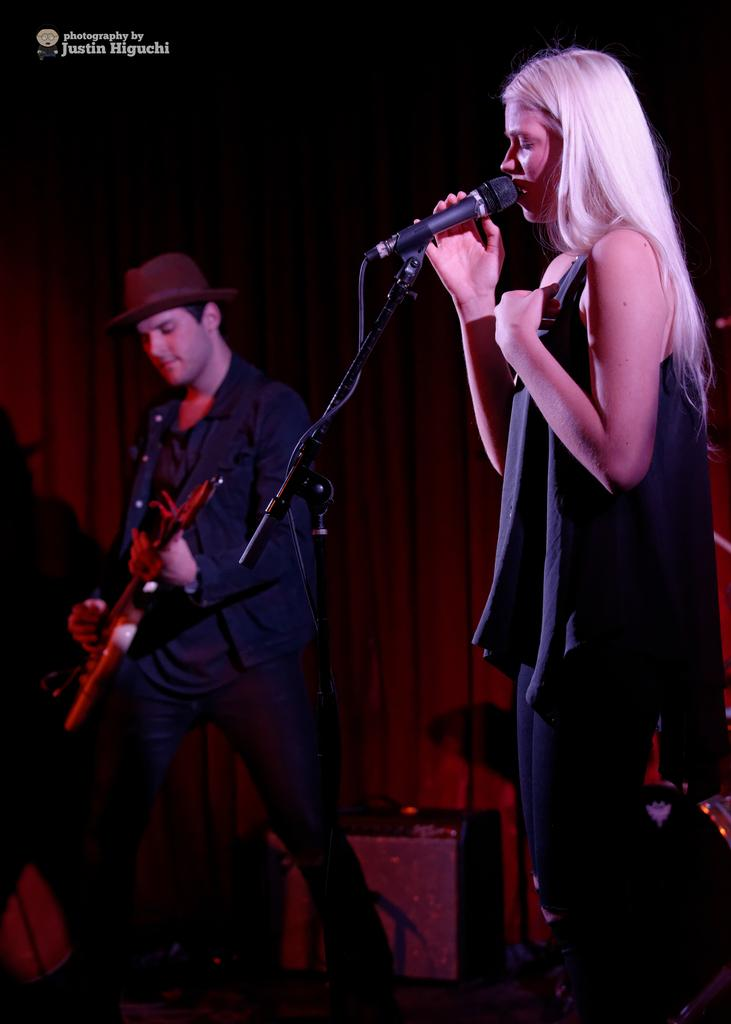What are the two people in the image doing? The man is holding a guitar, and the woman is holding a microphone. Can you describe the man's appearance in the image? The man is wearing a cap. What is the woman holding in the image? The woman is holding a microphone. What type of roof can be seen on the box in the image? There is no box or roof present in the image. What kind of border surrounds the image? The image does not show a border; it is a photograph or illustration with its own edges. 